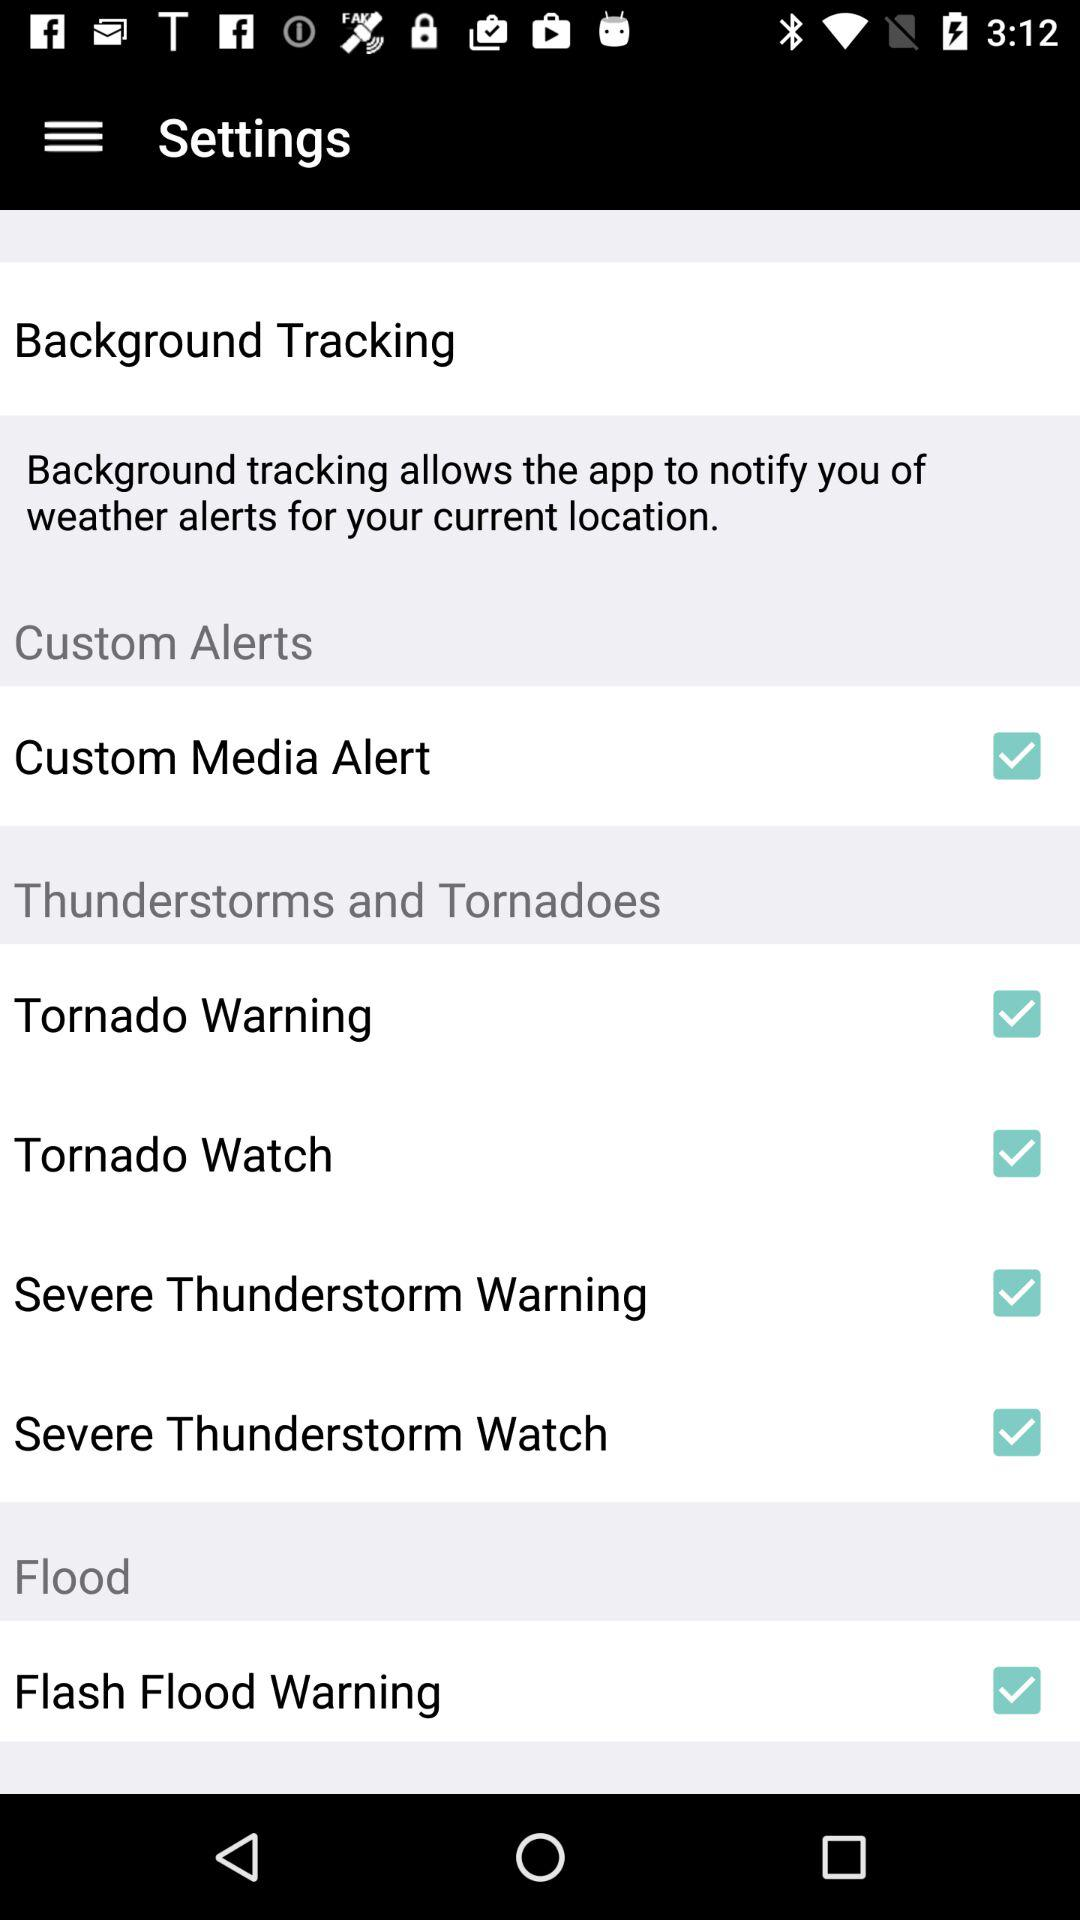How many items in the Custom Alerts section have a checkbox?
Answer the question using a single word or phrase. 1 